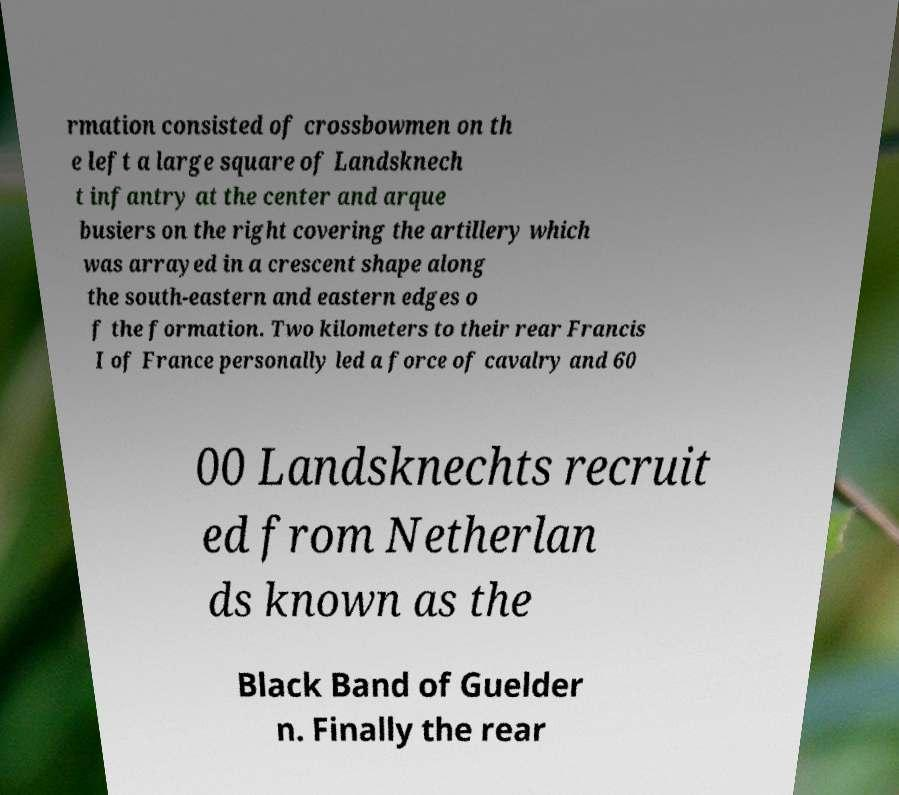Can you read and provide the text displayed in the image?This photo seems to have some interesting text. Can you extract and type it out for me? rmation consisted of crossbowmen on th e left a large square of Landsknech t infantry at the center and arque busiers on the right covering the artillery which was arrayed in a crescent shape along the south-eastern and eastern edges o f the formation. Two kilometers to their rear Francis I of France personally led a force of cavalry and 60 00 Landsknechts recruit ed from Netherlan ds known as the Black Band of Guelder n. Finally the rear 